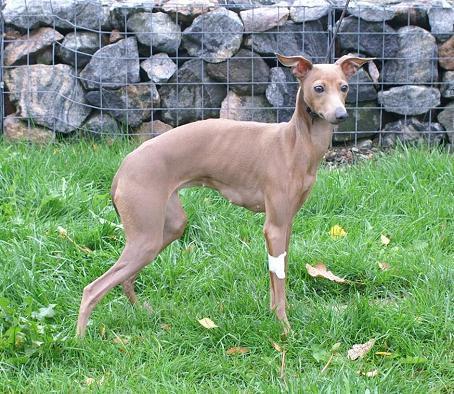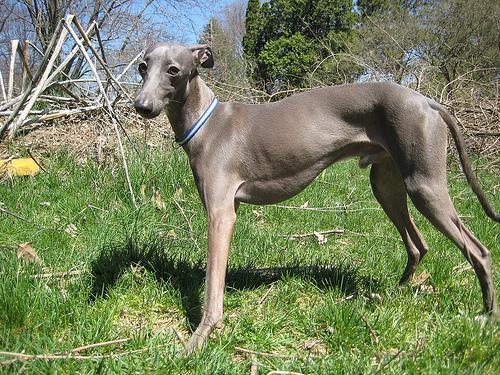The first image is the image on the left, the second image is the image on the right. Analyze the images presented: Is the assertion "The dog in one of the images is standing near a fence." valid? Answer yes or no. Yes. 